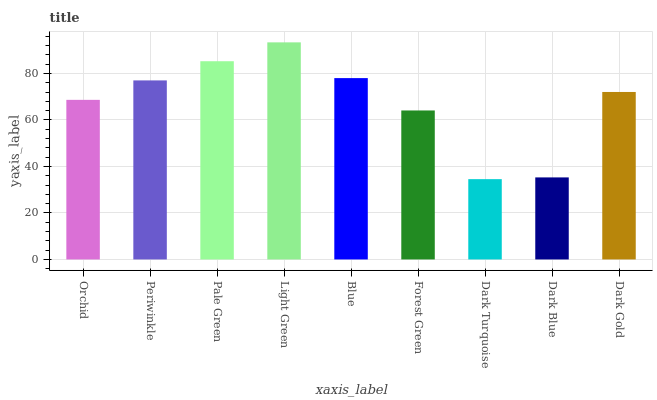Is Dark Turquoise the minimum?
Answer yes or no. Yes. Is Light Green the maximum?
Answer yes or no. Yes. Is Periwinkle the minimum?
Answer yes or no. No. Is Periwinkle the maximum?
Answer yes or no. No. Is Periwinkle greater than Orchid?
Answer yes or no. Yes. Is Orchid less than Periwinkle?
Answer yes or no. Yes. Is Orchid greater than Periwinkle?
Answer yes or no. No. Is Periwinkle less than Orchid?
Answer yes or no. No. Is Dark Gold the high median?
Answer yes or no. Yes. Is Dark Gold the low median?
Answer yes or no. Yes. Is Orchid the high median?
Answer yes or no. No. Is Dark Blue the low median?
Answer yes or no. No. 